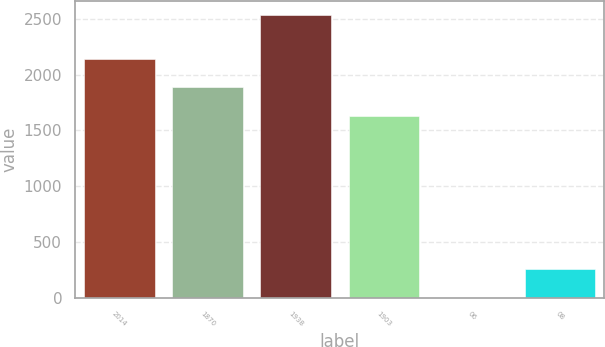<chart> <loc_0><loc_0><loc_500><loc_500><bar_chart><fcel>2014<fcel>1870<fcel>1938<fcel>1903<fcel>06<fcel>08<nl><fcel>2138.98<fcel>1885.49<fcel>2535<fcel>1632<fcel>0.14<fcel>253.63<nl></chart> 